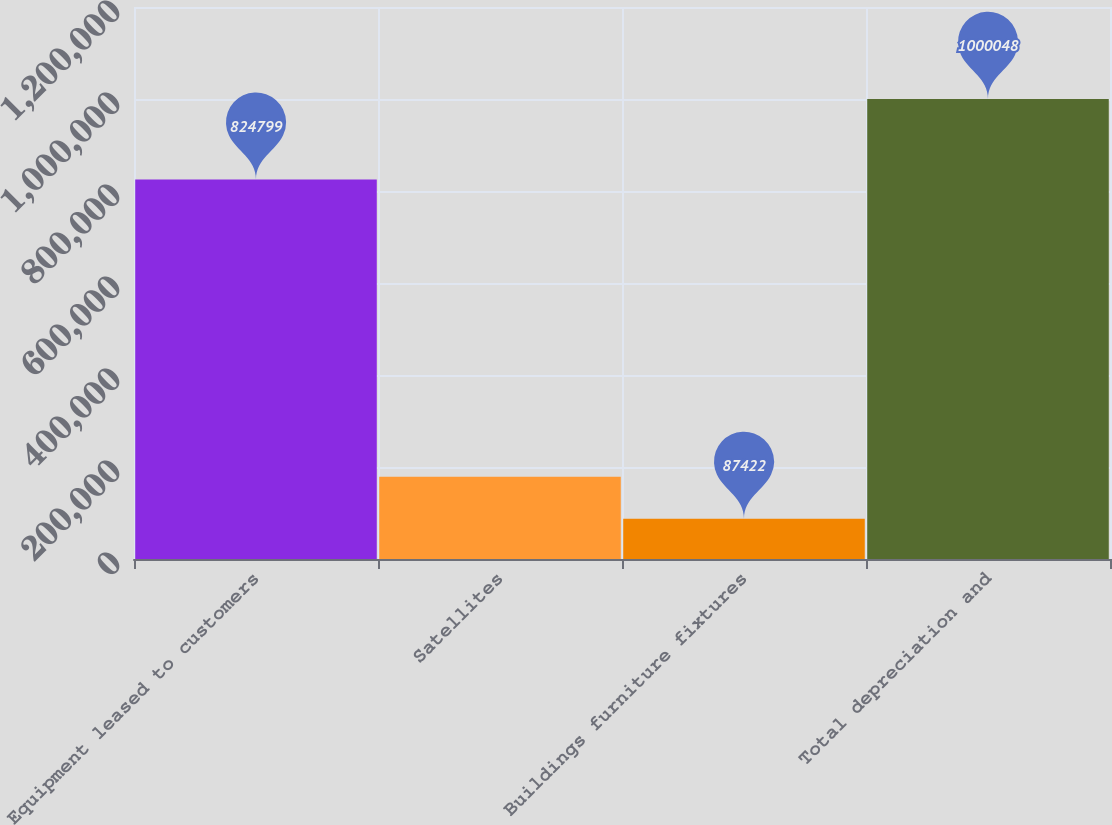Convert chart to OTSL. <chart><loc_0><loc_0><loc_500><loc_500><bar_chart><fcel>Equipment leased to customers<fcel>Satellites<fcel>Buildings furniture fixtures<fcel>Total depreciation and<nl><fcel>824799<fcel>178685<fcel>87422<fcel>1.00005e+06<nl></chart> 